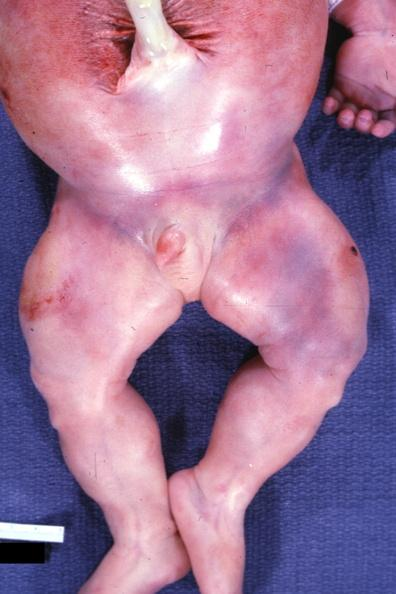what does this image show?
Answer the question using a single word or phrase. Lower extremities with increased muscle mass several other slides 